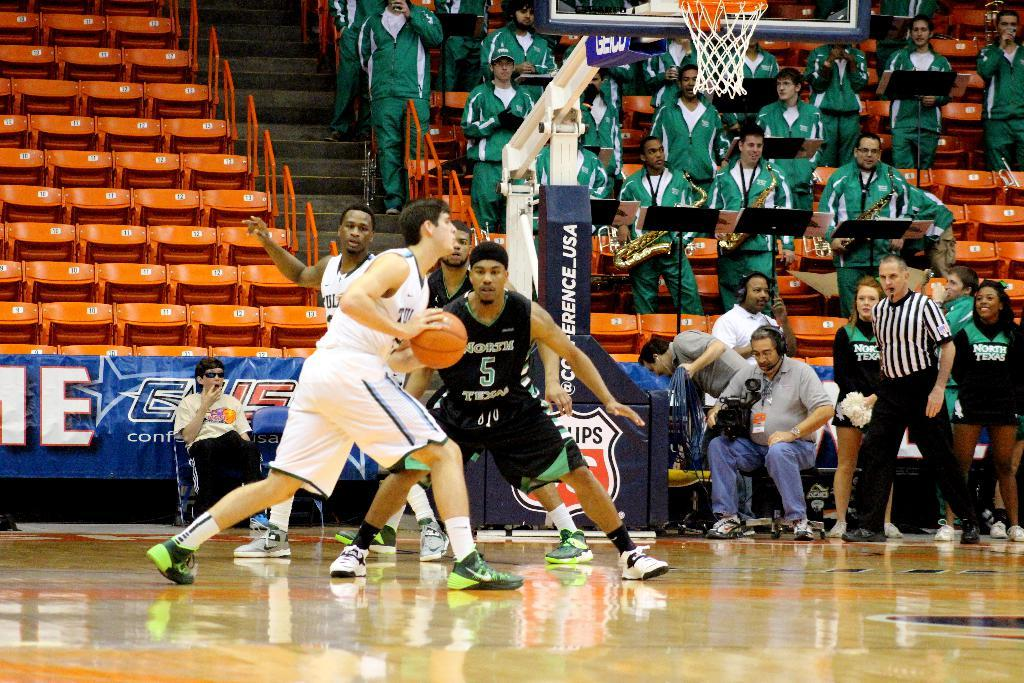Provide a one-sentence caption for the provided image. Basketball players in front of a hoop with the Conference USA logo on it. 